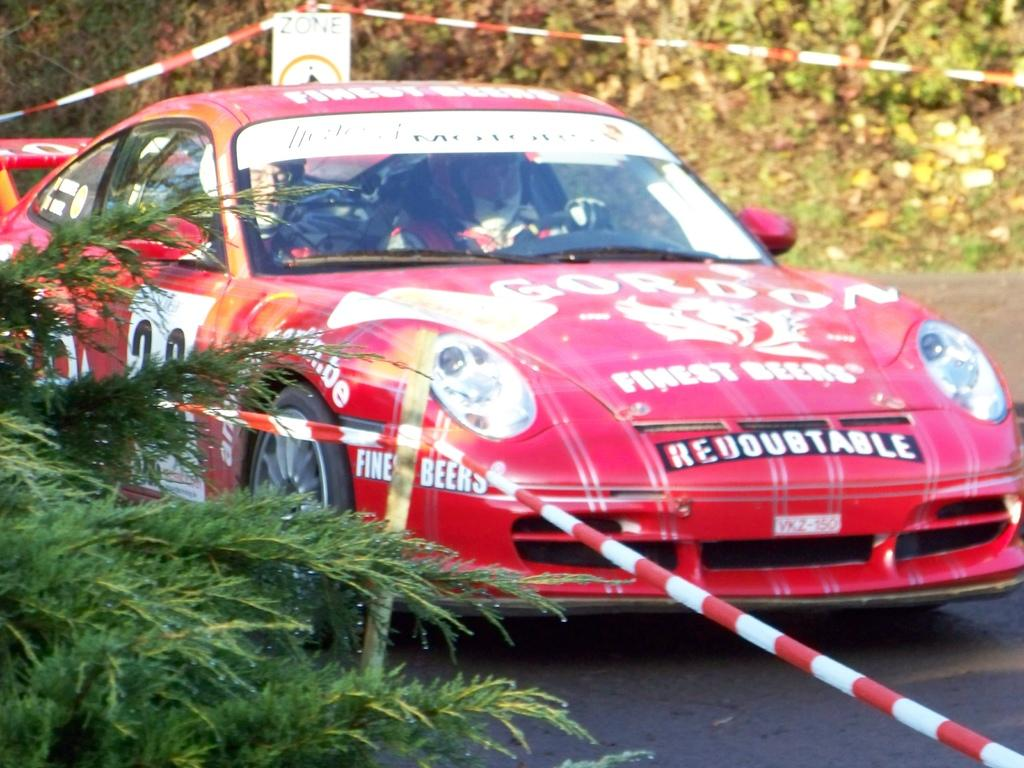What color is the car in the image? The car in the image is red. How many people are inside the car? There are two persons in the car. What is the color of the rod visible in the image? The rod visible in the image is red. What can be seen on the left side of the image? There are plants and the red color rod on the left side of the image. What type of humor can be seen in the image? There is no humor present in the image; it is a scene featuring a red color car, two persons, a red color rod, and plants on the left side. 